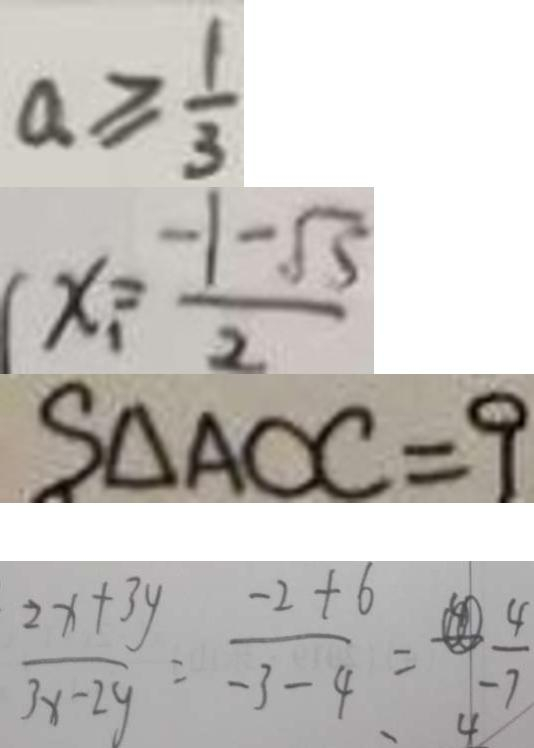<formula> <loc_0><loc_0><loc_500><loc_500>a \geq \frac { 1 } { 3 } 
 x _ { 1 } = \frac { - 1 - \sqrt { 5 } } { 2 } 
 S _ { \Delta A O C } = 9 
 \frac { 2 x + 3 y } { 3 x - 2 y } = - \frac { - 2 + 6 } { - 3 - 4 } = \frac { 4 } { - 7 }</formula> 